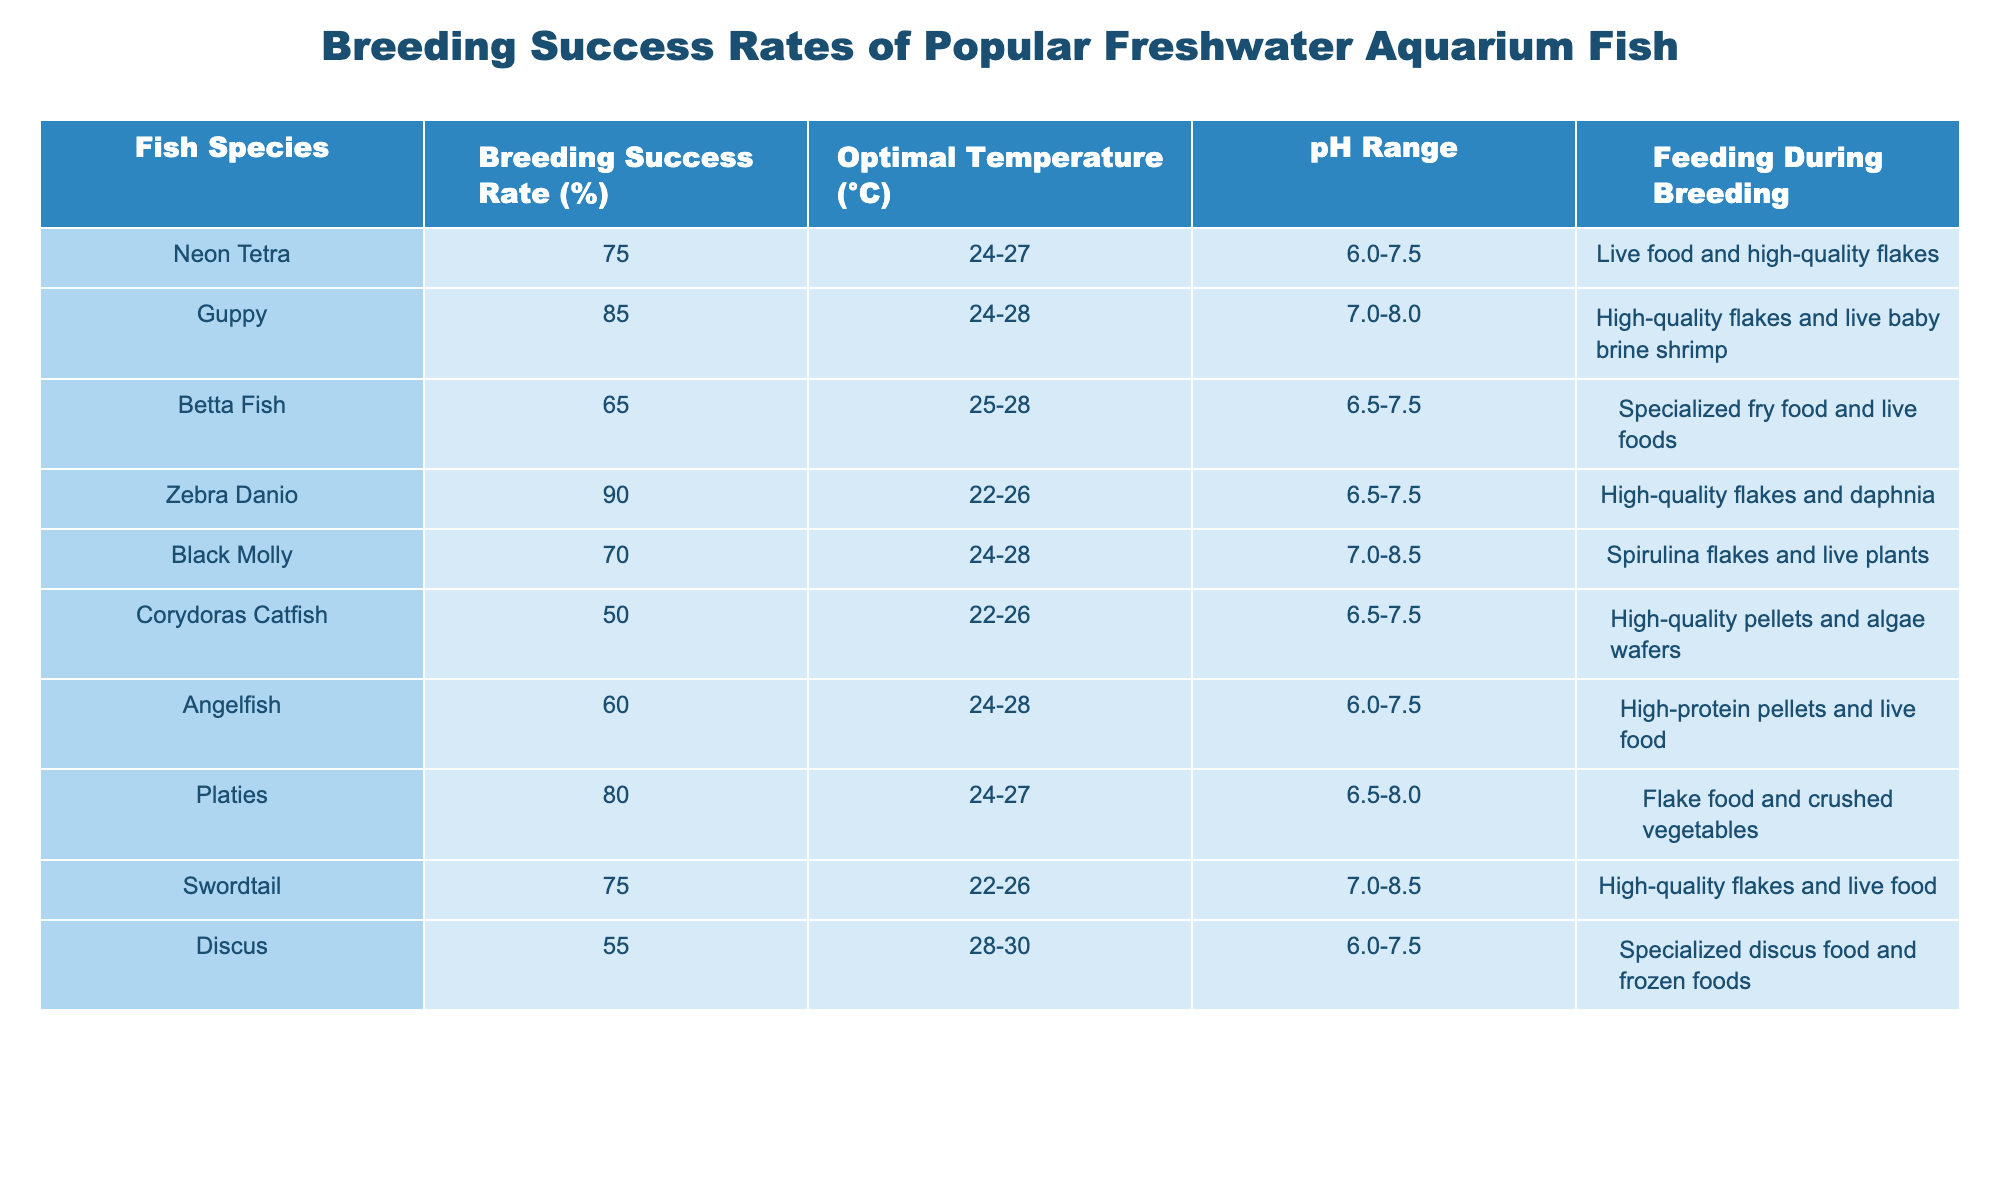What is the breeding success rate of Guppies? According to the table, the breeding success rate of Guppies is listed directly as 85%.
Answer: 85% Which fish species has the lowest breeding success rate? The table shows that Corydoras Catfish has the lowest breeding success rate at 50%.
Answer: 50% What is the average breeding success rate of the fish species listed in the table? To find the average, we add the breeding success rates: (75 + 85 + 65 + 90 + 70 + 50 + 60 + 80 + 75 + 55) =  75. The total number of species is 10, so we divide by 10 to get 75/10 = 75%.
Answer: 75% Is the Zebra Danio's breeding success rate higher than that of the Angelfish? The table shows that the Zebra Danio's breeding success rate is 90%, whereas the Angelfish's is 60%. Since 90% is greater than 60%, the answer is yes.
Answer: Yes What is the difference in breeding success rates between the highest and lowest species in the table? Zebra Danio has the highest success rate at 90% and Corydoras Catfish has the lowest at 50%. The difference is calculated as 90% - 50% = 40%.
Answer: 40% Which fish species requires the optimal temperature of 28°C for breeding success? The table indicates that both Guppy and Discus can have optimal temperatures of 28°C.
Answer: Guppy and Discus What percentage of fish species have a breeding success rate of 70% or more? The successful species are Neon Tetra, Guppy, Zebra Danio, Platies, and Swordtail, totaling 5 species with rates of 75%, 85%, 90%, 80%, and 75%. Since there are 10 total species, the percentage is (5/10) * 100 = 50%.
Answer: 50% Which fish requires specialized fry food during breeding? The table notes that Betta Fish requires specialized fry food during breeding.
Answer: Betta Fish If you were to breed fish at a pH range of 6.0-7.5, which species could you choose from the table? The species that can breed at a pH range of 6.0-7.5 are Neon Tetra, Betta Fish, and Angelfish, as indicated in the table.
Answer: Neon Tetra, Betta Fish, Angelfish How many fish species have an optimal temperature range of 24°C or above? The species with optimal temperatures of 24°C or above are Neon Tetra, Guppy, Betta Fish, Black Molly, Angelfish, Platies, and Swordtail, totaling 7 species.
Answer: 7 